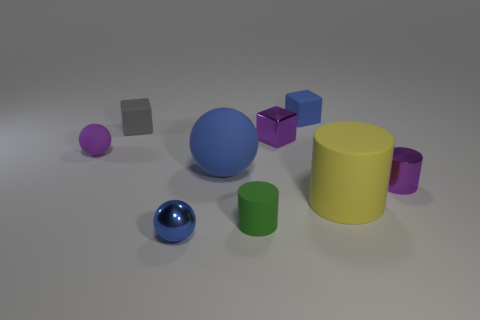Add 1 blue shiny blocks. How many objects exist? 10 Subtract all cylinders. How many objects are left? 6 Add 7 tiny gray objects. How many tiny gray objects exist? 8 Subtract 0 brown cubes. How many objects are left? 9 Subtract all large blue metallic objects. Subtract all gray rubber objects. How many objects are left? 8 Add 8 purple shiny cubes. How many purple shiny cubes are left? 9 